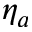Convert formula to latex. <formula><loc_0><loc_0><loc_500><loc_500>\eta _ { a }</formula> 